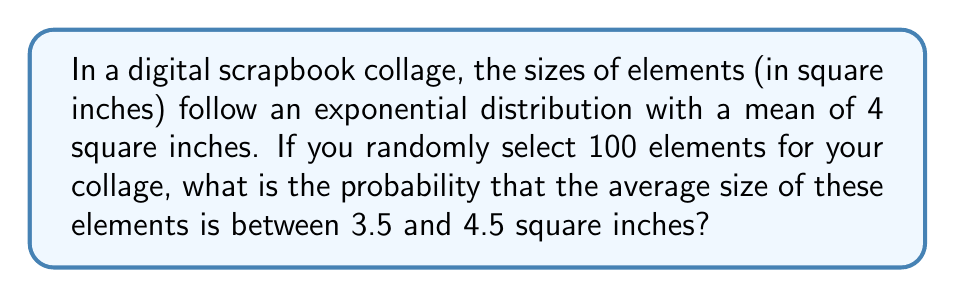What is the answer to this math problem? Let's approach this step-by-step:

1) First, recall that for an exponential distribution with mean $\mu$, the rate parameter $\lambda = \frac{1}{\mu}$. Here, $\mu = 4$, so $\lambda = \frac{1}{4}$.

2) The sample mean $\bar{X}$ of n independent, identically distributed random variables follows an approximately normal distribution when n is large (n ≥ 30 is usually considered sufficient). This is due to the Central Limit Theorem.

3) The mean of $\bar{X}$ is equal to the population mean $\mu$, which is 4 in this case.

4) The variance of $\bar{X}$ is $\frac{\sigma^2}{n}$, where $\sigma^2$ is the population variance. For an exponential distribution, $\sigma^2 = \frac{1}{\lambda^2} = \mu^2 = 4^2 = 16$.

5) So, the standard deviation of $\bar{X}$ is $\sqrt{\frac{\sigma^2}{n}} = \sqrt{\frac{16}{100}} = 0.4$.

6) We want to find $P(3.5 < \bar{X} < 4.5)$. We can standardize this to z-scores:

   $P(\frac{3.5 - 4}{0.4} < Z < \frac{4.5 - 4}{0.4}) = P(-1.25 < Z < 1.25)$

7) Using a standard normal table or calculator, we can find:

   $P(Z < 1.25) - P(Z < -1.25) = 0.8944 - 0.1056 = 0.7888$

Therefore, the probability is approximately 0.7888 or 78.88%.
Answer: 0.7888 